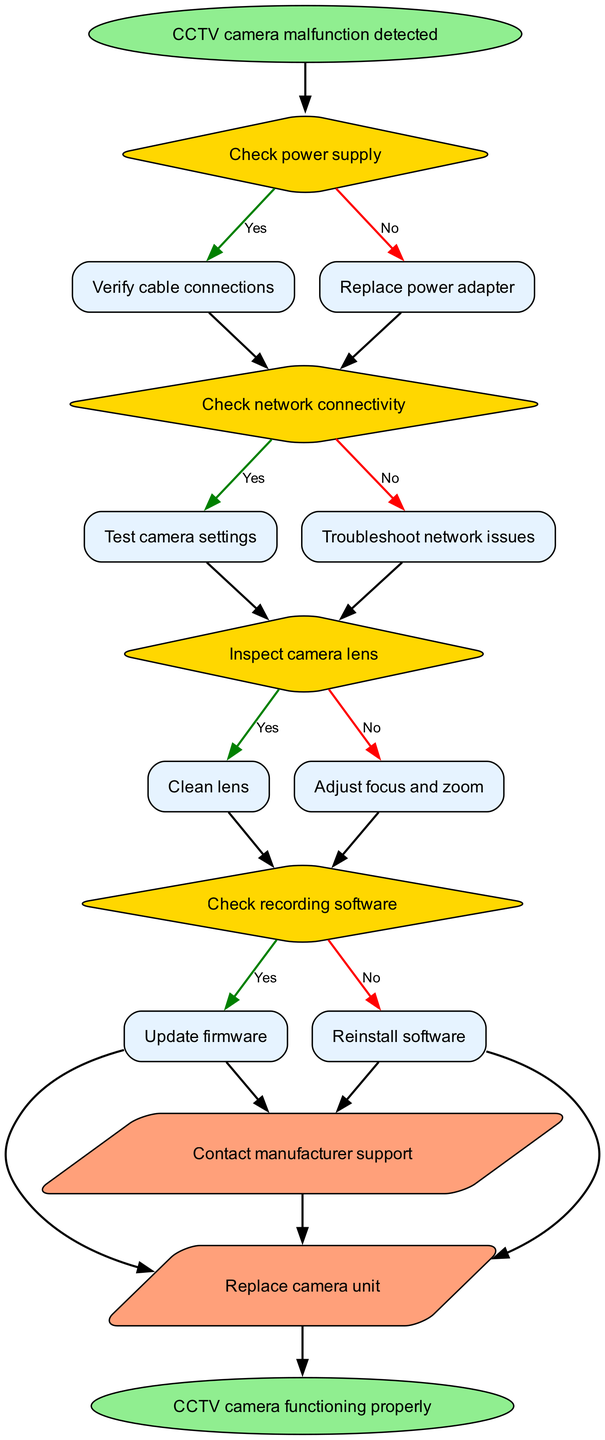What is the starting point of the flow chart? The starting point of the flow chart is identified as “CCTV camera malfunction detected,” which signifies the initial state from which the troubleshooting process begins.
Answer: CCTV camera malfunction detected How many decision nodes are present in the diagram? Upon reviewing the diagram, there are four separate decision nodes that represent various troubleshooting steps to evaluate the malfunction of the CCTV camera.
Answer: 4 What action should be taken if the network connectivity is not working? The flow indicates that if network connectivity is not functioning, the next step would be to troubleshoot network issues instead of checking camera settings, which reflects the logical flow of the troubleshooting process.
Answer: Troubleshoot network issues What action follows after cleaning the camera lens? According to the diagram's flow, after cleaning the camera lens, the next step would be to adjust focus and zoom if the inspection of the camera lens is necessary.
Answer: Adjust focus and zoom What do you do if the recording software is functioning? If the recording software is functioning properly, the next step is to update the firmware, as per the structural flow of the diagram.
Answer: Update firmware If the power supply is fine, what should you verify next? If the power supply checks out with no issues, the next step will be to verify cable connections, as indicated in the flow chart to ensure complete troubleshooting is conducted.
Answer: Verify cable connections What happens if none of the troubleshooting steps resolve the issue? The final step in the process indicates that if the troubleshooting efforts do not resolve the issue, the user should contact manufacturer support or replace the camera unit, as suggested in the flow chart.
Answer: Contact manufacturer support or Replace camera unit Which node does the last action point connect to? The last action node connects to the end node of the flow chart, which signifies the conclusion of the troubleshooting process with a sorted resolution.
Answer: CCTV camera functioning properly 